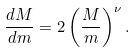Convert formula to latex. <formula><loc_0><loc_0><loc_500><loc_500>\frac { d M } { d m } = 2 \left ( \frac { M } { m } \right ) ^ { \nu } .</formula> 